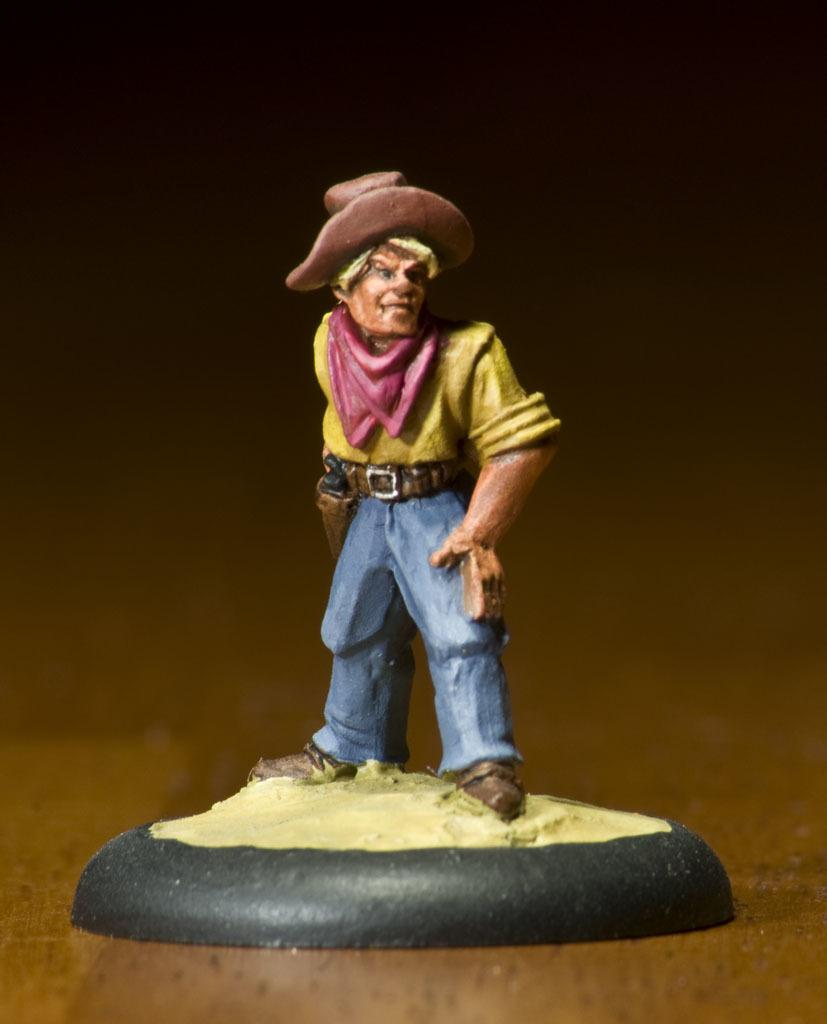What is the main subject of the image? There is a statue of a man in the image. Where is the statue located? The statue is on a table. What is the man in the statue wearing around his neck? The man in the statue is wearing a scarf around his neck. What type of headwear is the man in the statue wearing? The man in the statue is wearing a hat. What type of pest can be seen crawling on the statue in the image? There are no pests visible in the image; it only features a statue of a man. How does the statue lock itself when not in use? The statue is not a lockable object, so it cannot lock itself. 